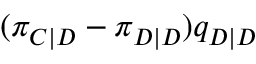Convert formula to latex. <formula><loc_0><loc_0><loc_500><loc_500>( \pi _ { C | D } - \pi _ { D | D } ) q _ { D | D }</formula> 